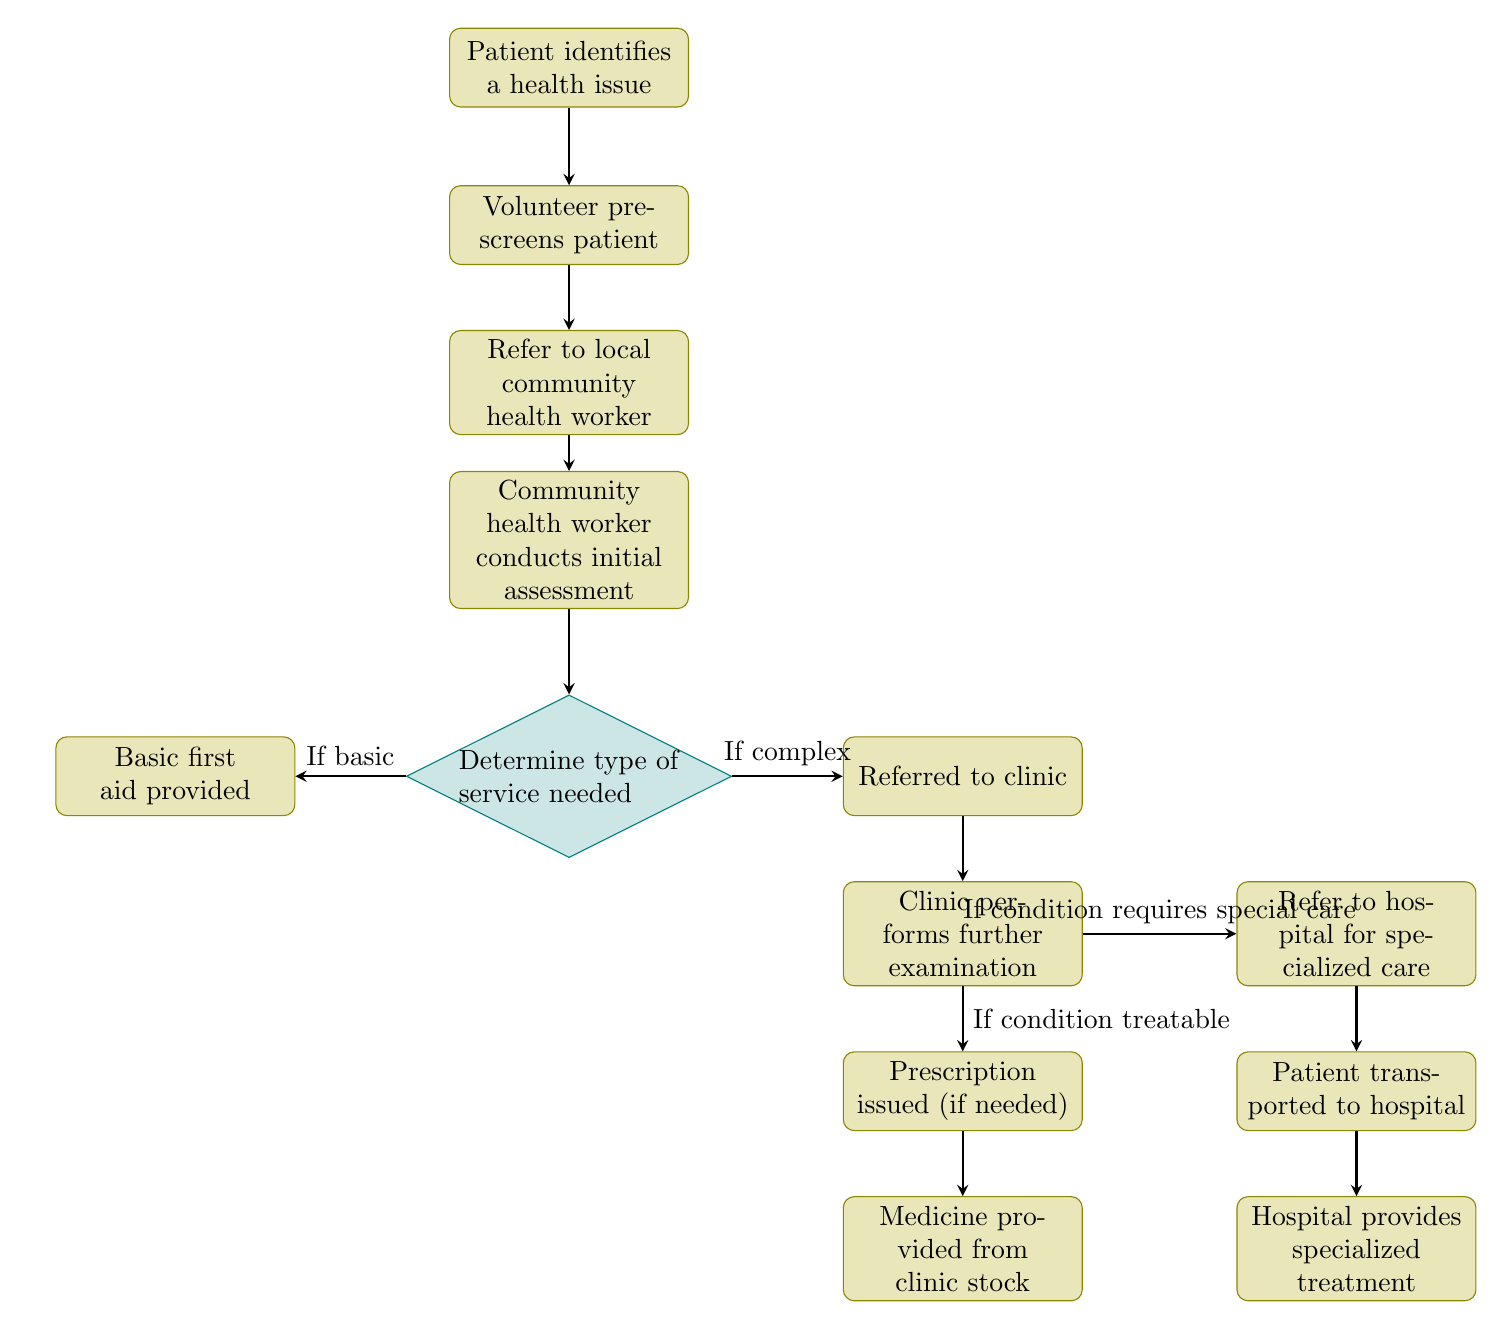What's the first node in the workflow? The first node is "Patient identifies a health issue," as it is the starting point of the flowchart indicating where the process begins.
Answer: Patient identifies a health issue How many nodes are there in total? By counting each labeled node in the diagram, there are a total of 13 nodes present in the workflow.
Answer: 13 What happens after the community health worker conducts the initial assessment? After the initial assessment by the community health worker, the next step is to "Determine type of service needed," which is a decision point in the flowchart.
Answer: Determine type of service needed If the service needed is complex, where does the workflow direct the patient? If the service needed is complex, the workflow directs the patient to "Referred to clinic," as indicated by the edge leading from the decision node to this process.
Answer: Referred to clinic What is the last step in the workflow? The last step in the workflow is "Hospital provides specialized treatment," which is the final action taken after transporting the patient to the hospital.
Answer: Hospital provides specialized treatment Which node provides basic first aid? The node that provides basic first aid is labeled "Basic first aid provided," which is reached if the determination of the service needed indicates a basic service.
Answer: Basic first aid provided What is the condition for issuing a prescription in the clinic? A prescription is issued if the condition is treatable, as indicated by the label on the arrow leading from the clinic examination node to the prescription node.
Answer: If condition treatable How does the patient reach the hospital from the clinic? The patient reaches the hospital after being referred to it from the clinic if the condition requires special care, followed by transportation to the hospital.
Answer: Transported to hospital Which two nodes lead to the medicine provision? The two nodes leading to the provision of medicine are "Prescription issued (if needed)" and "Medicine provided from clinic stock," indicating the process of obtaining medicine after evaluation.
Answer: Prescription issued, Medicine provided 